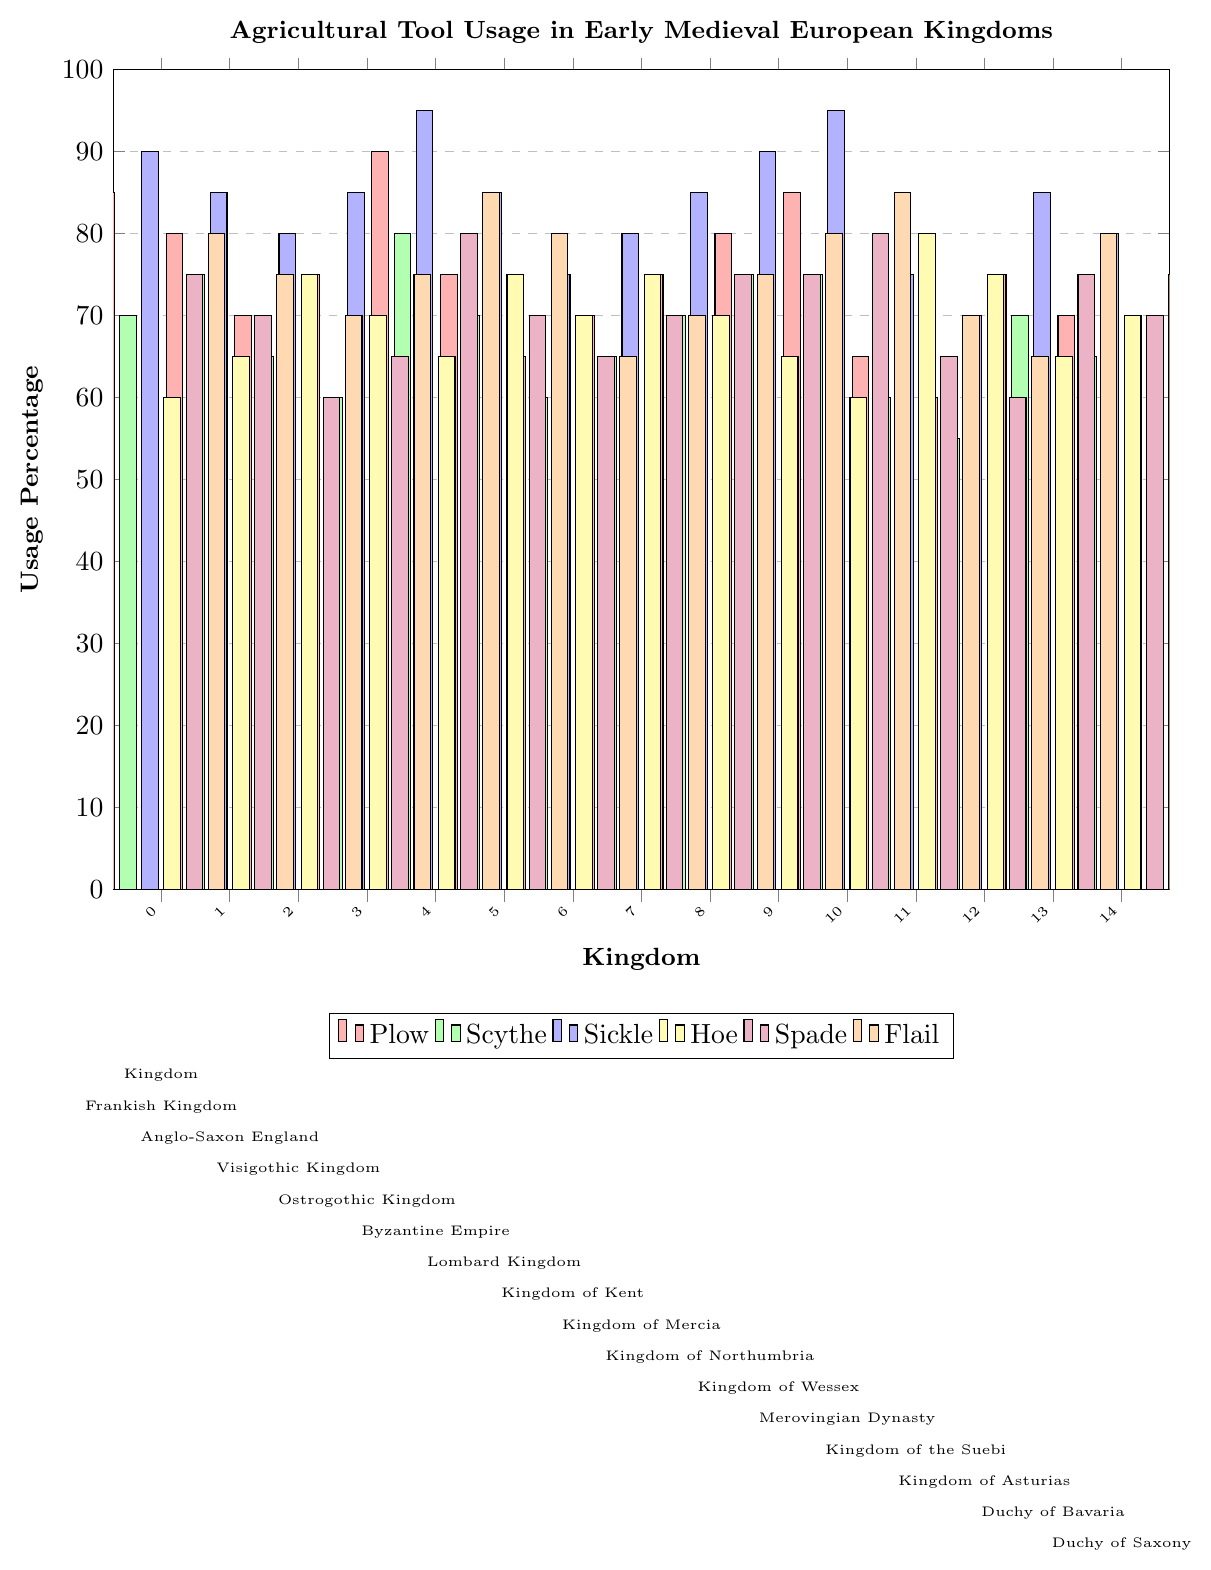What kingdom has the highest usage of plows? Identify the highest bar for the plow data (red bars). The Byzantine Empire shows the highest bar value for plows at 90.
Answer: Byzantine Empire Which tool has the lowest usage percentage in the Kingdom of Asturias? Look at the heights of the bars corresponding to the Kingdom of Asturias. The Hoe (yellow bar) has the lowest height, corresponding to a value of 60.
Answer: Hoe Compare the usage of sickles between the Frankish Kingdom and the Visigothic Kingdom. Which has higher usage? Refer to the heights of the blue bars for both kingdoms. The Frankish Kingdom's sickle usage is 90, while the Visigothic Kingdom's is 80. The Frankish Kingdom has higher usage.
Answer: Frankish Kingdom What is the average usage of flails in the Lombard Kingdom, Kingdom of Kent, and Kingdom of Wessex? Consider the orange bar values for the three kingdoms: Lombard Kingdom (80), Kingdom of Kent (65), and Kingdom of Wessex (80). The average is (80 + 65 + 80) / 3 = 75.
Answer: 75 Which kingdom shows the highest usage of hoes and what is the percentage? Look for the highest yellow bar in the plot. The Kingdom of the Suebi has the highest hoe usage at 80.
Answer: Kingdom of the Suebi, 80 How does the scythe usage in the Anglo-Saxon England compare to the Duchy of Saxony? Check the green bars for each kingdom. Anglo-Saxon England has a value of 75 while the Duchy of Saxony has a value of 65. The Anglo-Saxon England has higher scythe usage.
Answer: Anglo-Saxon England Which three kingdoms have the lowest usage of plows? Look at the heights of the red bars and identify the smallest three. The Kingdom of Asturias (60), Kingdom of Kent (65), and Kingdom of the Suebi (65) have the lowest plow usage.
Answer: Kingdom of Asturias, Kingdom of Kent, Kingdom of the Suebi What is the total usage percentage of spades across all kingdoms? Sum the purple bar values for all kingdoms: 75 + 70 + 60 + 65 + 80 + 70 + 65 + 70 + 75 + 75 + 80 + 65 + 60 + 75 + 70 = 1015.
Answer: 1015 Which kingdom has equal usage percentages for plows and flails? Identify the kingdoms where red and orange bars are of equal heights. The Frankish Kingdom has both plows and flails at 80%.
Answer: Frankish Kingdom 